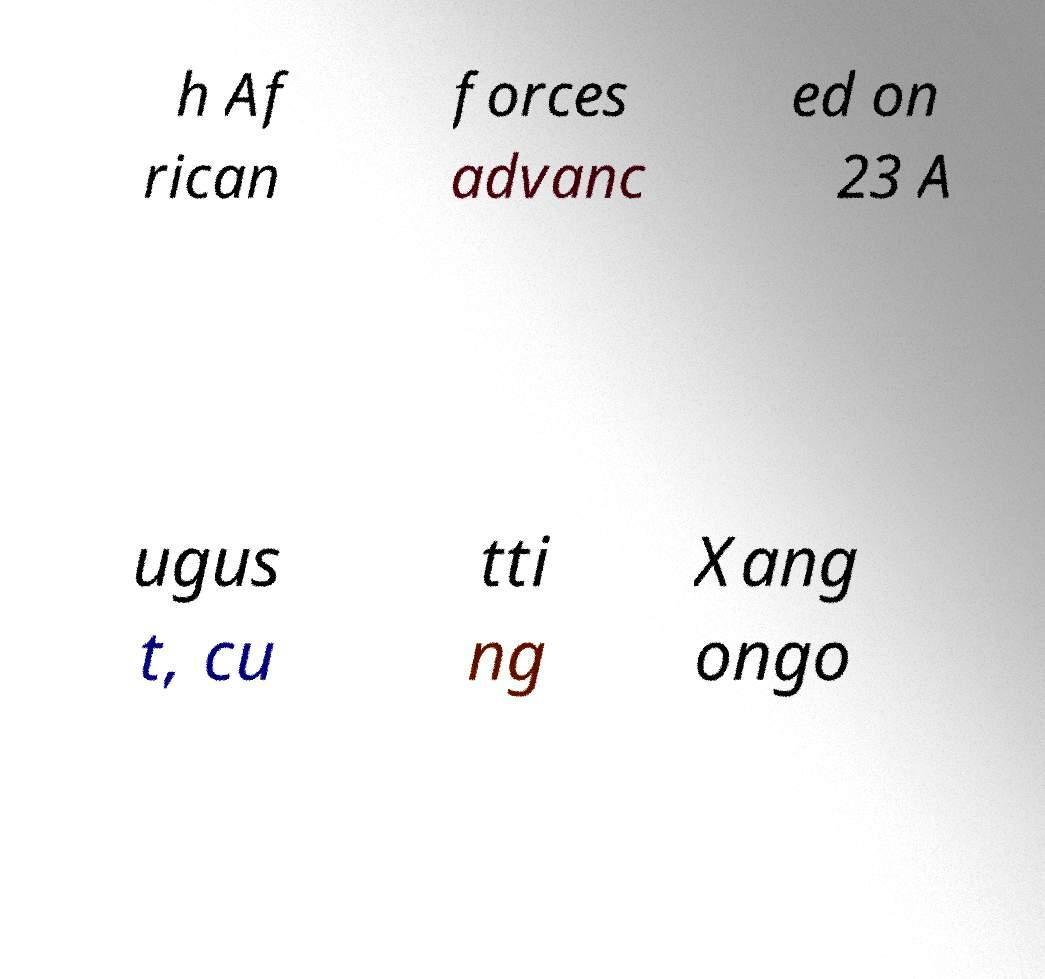Could you assist in decoding the text presented in this image and type it out clearly? h Af rican forces advanc ed on 23 A ugus t, cu tti ng Xang ongo 